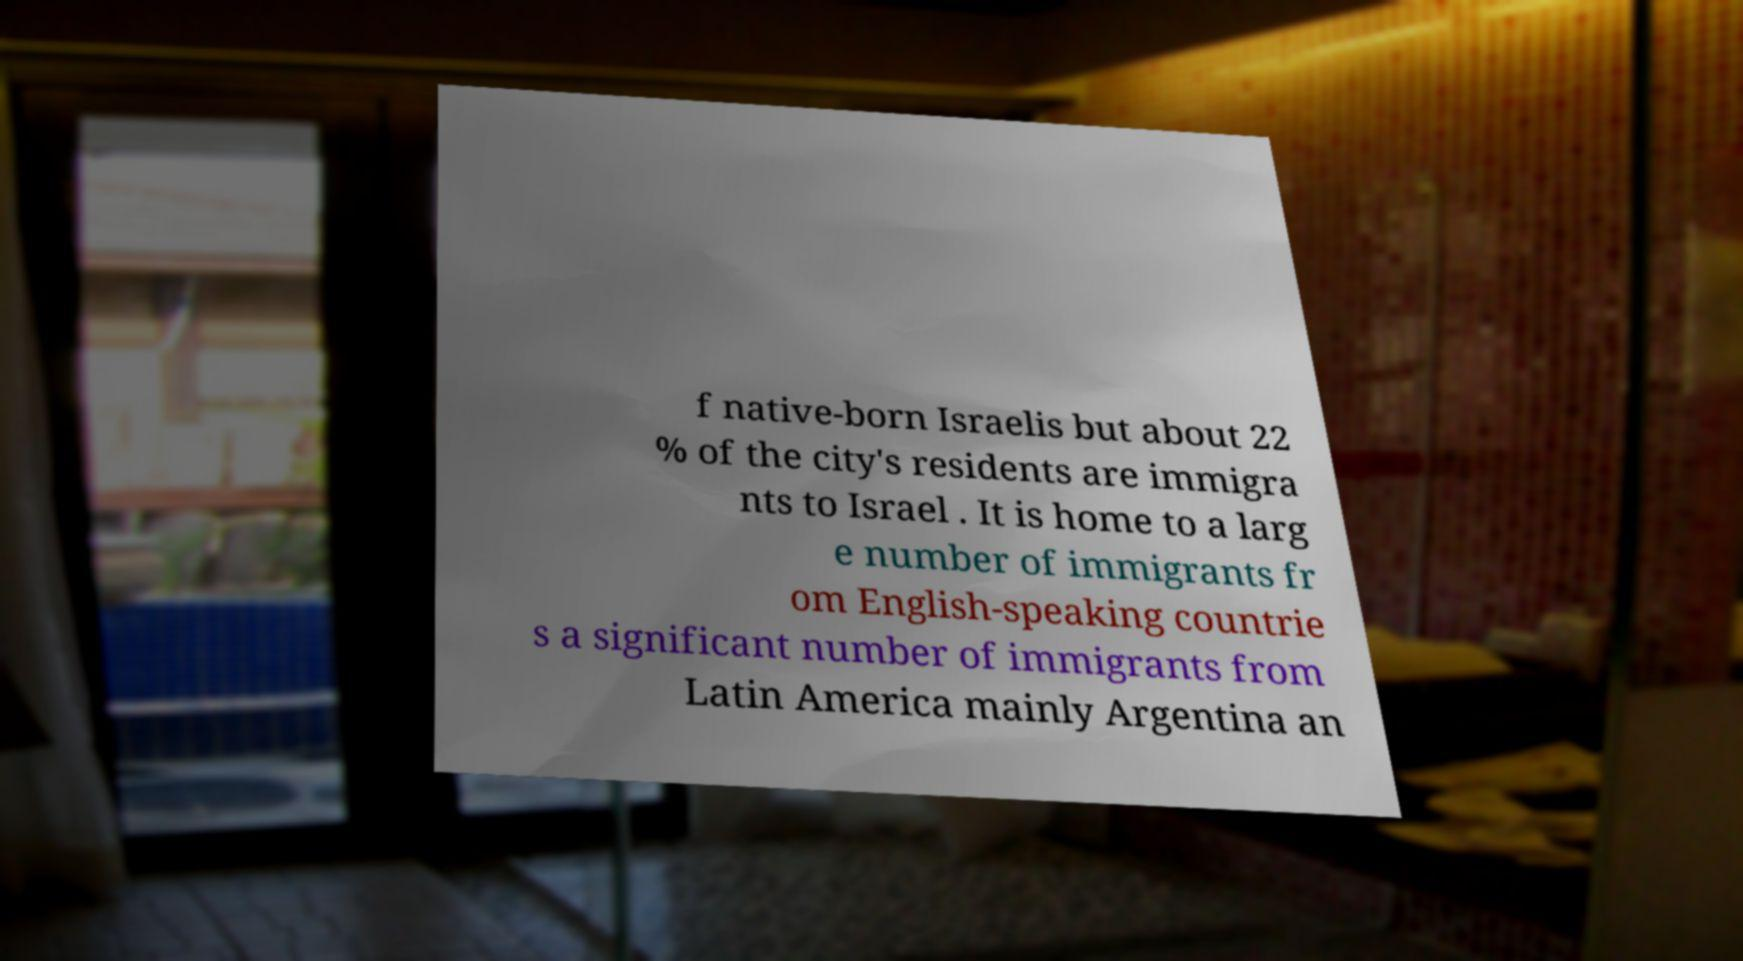Could you extract and type out the text from this image? f native-born Israelis but about 22 % of the city's residents are immigra nts to Israel . It is home to a larg e number of immigrants fr om English-speaking countrie s a significant number of immigrants from Latin America mainly Argentina an 